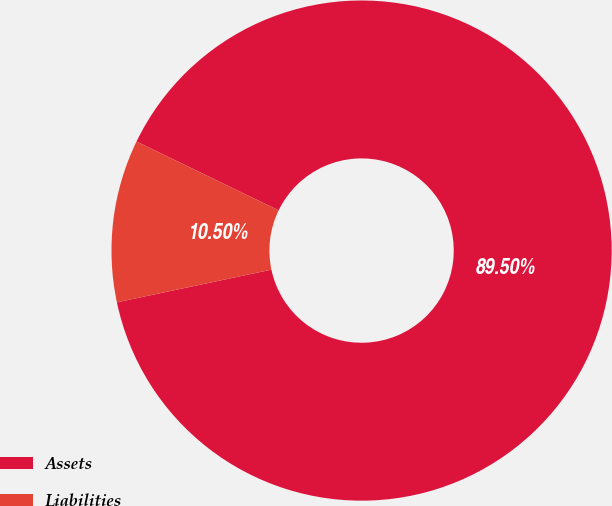Convert chart. <chart><loc_0><loc_0><loc_500><loc_500><pie_chart><fcel>Assets<fcel>Liabilities<nl><fcel>89.5%<fcel>10.5%<nl></chart> 